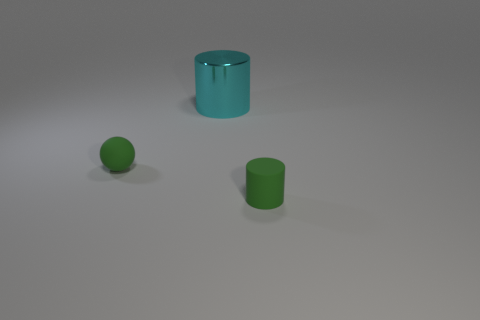Add 3 small things. How many objects exist? 6 Subtract 1 spheres. How many spheres are left? 0 Subtract all blue cubes. How many cyan cylinders are left? 1 Subtract all cylinders. How many objects are left? 1 Subtract all cyan metallic things. Subtract all tiny cylinders. How many objects are left? 1 Add 1 rubber spheres. How many rubber spheres are left? 2 Add 1 large red matte things. How many large red matte things exist? 1 Subtract 0 brown cubes. How many objects are left? 3 Subtract all yellow spheres. Subtract all green cubes. How many spheres are left? 1 